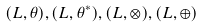<formula> <loc_0><loc_0><loc_500><loc_500>( L , \theta ) , ( L , \theta ^ { * } ) , ( L , \otimes ) , ( L , \oplus )</formula> 